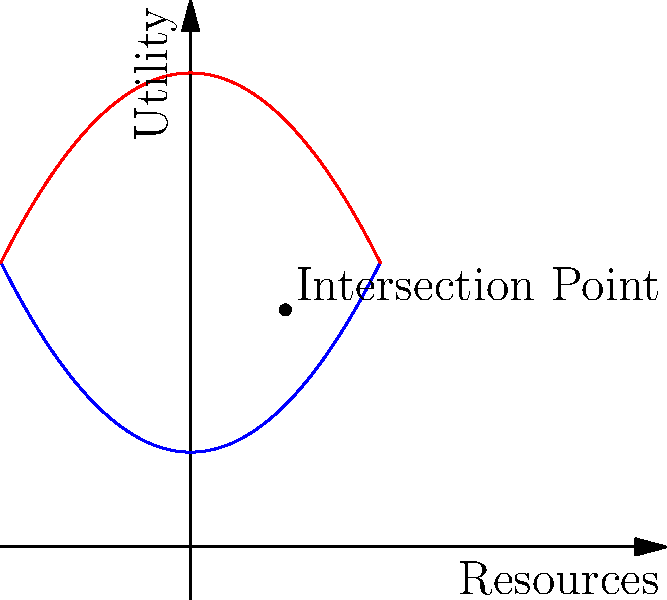As an economist, you are tasked with optimizing resource allocation between two demographic groups, A and B, whose utility functions are represented by the blue and red curves respectively. The utility functions are:

Group A: $U_A(x) = 0.5x^2 + 1$
Group B: $U_B(x) = -0.5x^2 + 5$

Where $x$ represents the amount of resources allocated. Assuming you have a total of 2 units of resources to distribute, what is the optimal allocation that maximizes the total utility for both groups combined? To solve this optimization problem, we'll follow these steps:

1) First, we need to find the total utility function:
   $U_{total}(x) = U_A(x) + U_B(2-x)$
   (Note: We use (2-x) for Group B because the total resources are 2)

2) Expand the equation:
   $U_{total}(x) = (0.5x^2 + 1) + (-0.5(2-x)^2 + 5)$

3) Simplify:
   $U_{total}(x) = 0.5x^2 + 1 + (-0.5(4-4x+x^2) + 5)$
   $U_{total}(x) = 0.5x^2 + 1 - 2 + 2x - 0.5x^2 + 5$
   $U_{total}(x) = 2x + 4$

4) To find the maximum, we differentiate and set to zero:
   $\frac{d}{dx}U_{total}(x) = 2 = 0$

5) The derivative is a constant, which means the function is linear and doesn't have a maximum or minimum within the domain.

6) Therefore, we need to check the endpoints of our domain (0 and 2):
   At x = 0: $U_{total}(0) = 4$
   At x = 2: $U_{total}(2) = 8$

7) The maximum utility is achieved when x = 2, meaning all resources should be allocated to Group A.
Answer: Allocate all 2 units to Group A. 